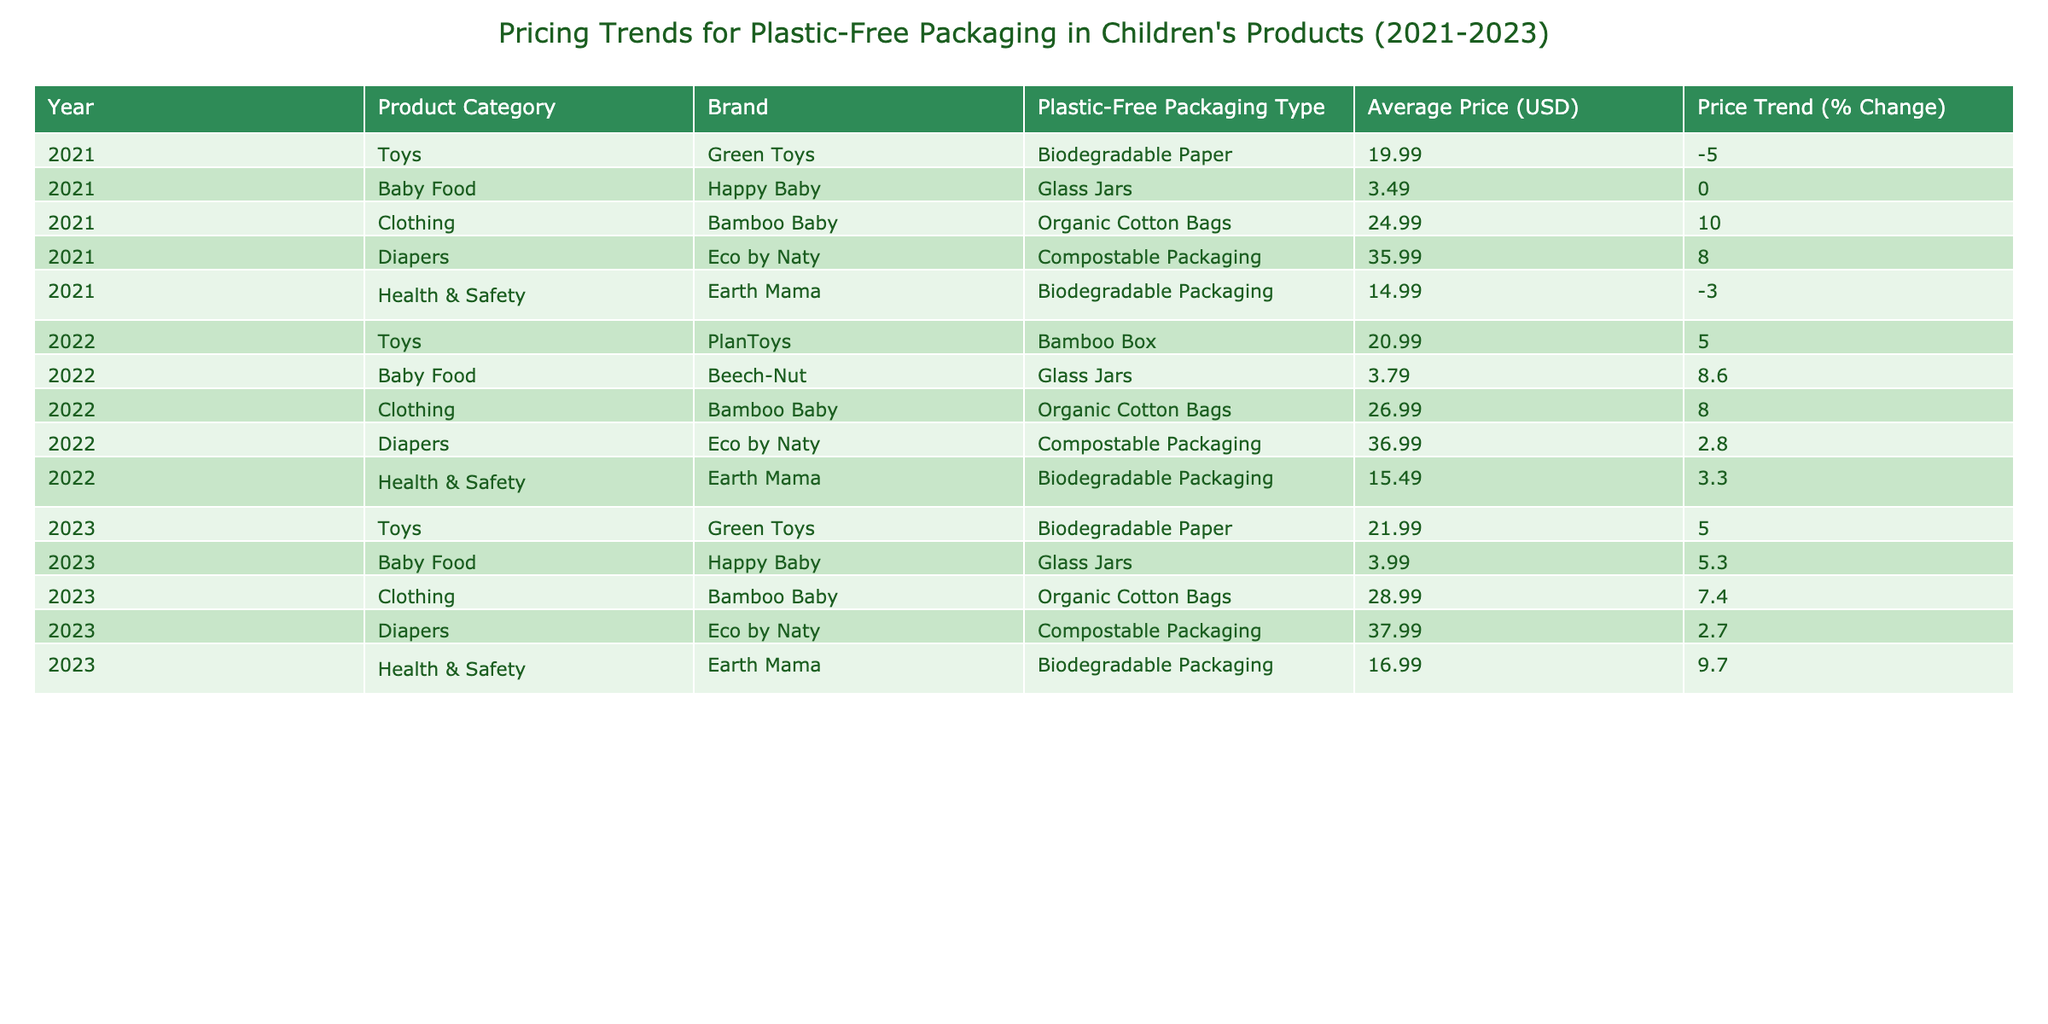What was the average price of baby food in 2023? From the table under the Baby Food category for 2023, the average price is listed as 3.99 USD.
Answer: 3.99 USD Which product category experienced the highest price increase from 2021 to 2022? By comparing the price trends from 2021 to 2022, Baby Food (from 3.49 to 3.79, a change of 8.6%) shows the highest percent increase compared to other categories.
Answer: Baby Food Did the average price of diapers increase from 2021 to 2023? Comparing the average prices from the table, diapers were 35.99 USD in 2021, increased to 36.99 USD in 2022, and then to 37.99 USD in 2023, showing a consistent increase.
Answer: Yes What is the price difference for toys between 2021 and 2023? The average price of toys in 2021 was 19.99 USD and in 2023 it is 21.99 USD, resulting in a price difference of 21.99 - 19.99 = 2.00 USD.
Answer: 2.00 USD Which brand has the highest average price for clothing in 2023? The table lists Bamboo Baby as the only brand for clothing in 2023 with an average price of 28.99 USD, making it the highest by default in that category.
Answer: Bamboo Baby 